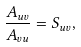Convert formula to latex. <formula><loc_0><loc_0><loc_500><loc_500>\frac { A _ { u v } } { A _ { v u } } = S _ { u v } ,</formula> 